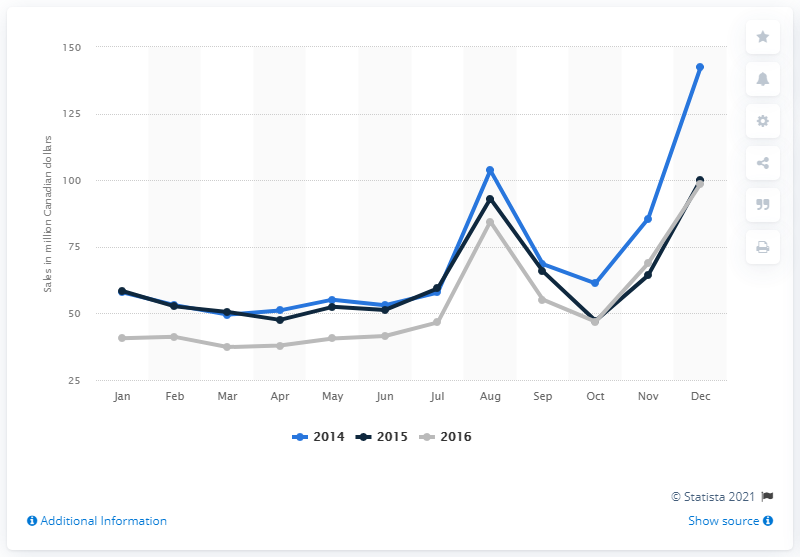Indicate a few pertinent items in this graphic. In December 2014, the retail sales of stationery, office supplies, cards, gift wrap, and party supplies in Canada totaled 142.5. 